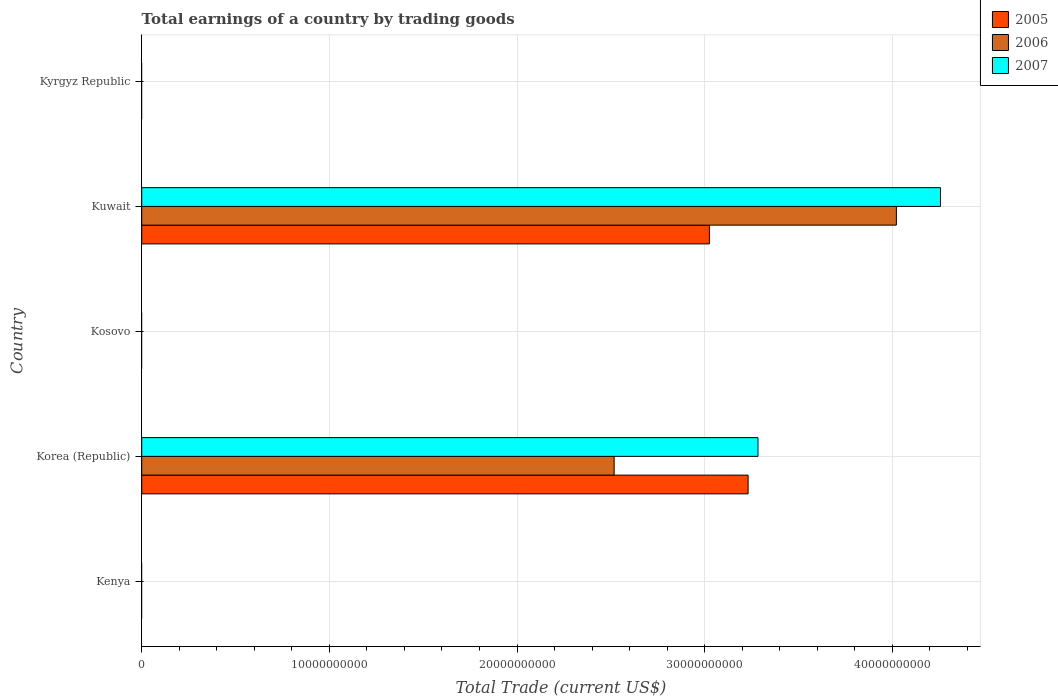Are the number of bars per tick equal to the number of legend labels?
Offer a very short reply. No. Are the number of bars on each tick of the Y-axis equal?
Keep it short and to the point. No. How many bars are there on the 3rd tick from the bottom?
Your response must be concise. 0. What is the label of the 1st group of bars from the top?
Provide a short and direct response. Kyrgyz Republic. In how many cases, is the number of bars for a given country not equal to the number of legend labels?
Provide a short and direct response. 3. What is the total earnings in 2006 in Korea (Republic)?
Provide a short and direct response. 2.52e+1. Across all countries, what is the maximum total earnings in 2006?
Your response must be concise. 4.02e+1. Across all countries, what is the minimum total earnings in 2007?
Your answer should be very brief. 0. In which country was the total earnings in 2006 maximum?
Keep it short and to the point. Kuwait. What is the total total earnings in 2007 in the graph?
Offer a terse response. 7.54e+1. What is the difference between the total earnings in 2005 in Korea (Republic) and that in Kuwait?
Your answer should be very brief. 2.06e+09. What is the average total earnings in 2007 per country?
Offer a terse response. 1.51e+1. What is the difference between the total earnings in 2005 and total earnings in 2007 in Korea (Republic)?
Give a very brief answer. -5.25e+08. In how many countries, is the total earnings in 2007 greater than 2000000000 US$?
Make the answer very short. 2. What is the difference between the highest and the lowest total earnings in 2007?
Offer a very short reply. 4.26e+1. Is it the case that in every country, the sum of the total earnings in 2005 and total earnings in 2006 is greater than the total earnings in 2007?
Offer a very short reply. No. How many bars are there?
Keep it short and to the point. 6. Are all the bars in the graph horizontal?
Give a very brief answer. Yes. How many countries are there in the graph?
Keep it short and to the point. 5. What is the difference between two consecutive major ticks on the X-axis?
Offer a very short reply. 1.00e+1. Are the values on the major ticks of X-axis written in scientific E-notation?
Give a very brief answer. No. Where does the legend appear in the graph?
Your answer should be compact. Top right. How many legend labels are there?
Keep it short and to the point. 3. What is the title of the graph?
Provide a short and direct response. Total earnings of a country by trading goods. What is the label or title of the X-axis?
Your answer should be very brief. Total Trade (current US$). What is the label or title of the Y-axis?
Your response must be concise. Country. What is the Total Trade (current US$) of 2006 in Kenya?
Your answer should be very brief. 0. What is the Total Trade (current US$) of 2005 in Korea (Republic)?
Give a very brief answer. 3.23e+1. What is the Total Trade (current US$) of 2006 in Korea (Republic)?
Make the answer very short. 2.52e+1. What is the Total Trade (current US$) of 2007 in Korea (Republic)?
Offer a terse response. 3.28e+1. What is the Total Trade (current US$) of 2006 in Kosovo?
Offer a very short reply. 0. What is the Total Trade (current US$) in 2007 in Kosovo?
Offer a terse response. 0. What is the Total Trade (current US$) in 2005 in Kuwait?
Offer a very short reply. 3.02e+1. What is the Total Trade (current US$) in 2006 in Kuwait?
Your response must be concise. 4.02e+1. What is the Total Trade (current US$) of 2007 in Kuwait?
Provide a succinct answer. 4.26e+1. What is the Total Trade (current US$) of 2005 in Kyrgyz Republic?
Offer a very short reply. 0. What is the Total Trade (current US$) in 2006 in Kyrgyz Republic?
Provide a succinct answer. 0. Across all countries, what is the maximum Total Trade (current US$) of 2005?
Provide a succinct answer. 3.23e+1. Across all countries, what is the maximum Total Trade (current US$) in 2006?
Offer a very short reply. 4.02e+1. Across all countries, what is the maximum Total Trade (current US$) of 2007?
Offer a very short reply. 4.26e+1. Across all countries, what is the minimum Total Trade (current US$) of 2006?
Your answer should be compact. 0. What is the total Total Trade (current US$) in 2005 in the graph?
Your answer should be compact. 6.26e+1. What is the total Total Trade (current US$) in 2006 in the graph?
Your response must be concise. 6.54e+1. What is the total Total Trade (current US$) of 2007 in the graph?
Offer a very short reply. 7.54e+1. What is the difference between the Total Trade (current US$) in 2005 in Korea (Republic) and that in Kuwait?
Provide a succinct answer. 2.06e+09. What is the difference between the Total Trade (current US$) of 2006 in Korea (Republic) and that in Kuwait?
Give a very brief answer. -1.50e+1. What is the difference between the Total Trade (current US$) in 2007 in Korea (Republic) and that in Kuwait?
Offer a terse response. -9.73e+09. What is the difference between the Total Trade (current US$) in 2005 in Korea (Republic) and the Total Trade (current US$) in 2006 in Kuwait?
Your answer should be compact. -7.90e+09. What is the difference between the Total Trade (current US$) in 2005 in Korea (Republic) and the Total Trade (current US$) in 2007 in Kuwait?
Offer a terse response. -1.03e+1. What is the difference between the Total Trade (current US$) in 2006 in Korea (Republic) and the Total Trade (current US$) in 2007 in Kuwait?
Your response must be concise. -1.74e+1. What is the average Total Trade (current US$) in 2005 per country?
Offer a very short reply. 1.25e+1. What is the average Total Trade (current US$) of 2006 per country?
Make the answer very short. 1.31e+1. What is the average Total Trade (current US$) of 2007 per country?
Give a very brief answer. 1.51e+1. What is the difference between the Total Trade (current US$) in 2005 and Total Trade (current US$) in 2006 in Korea (Republic)?
Give a very brief answer. 7.14e+09. What is the difference between the Total Trade (current US$) of 2005 and Total Trade (current US$) of 2007 in Korea (Republic)?
Your response must be concise. -5.25e+08. What is the difference between the Total Trade (current US$) of 2006 and Total Trade (current US$) of 2007 in Korea (Republic)?
Ensure brevity in your answer.  -7.66e+09. What is the difference between the Total Trade (current US$) in 2005 and Total Trade (current US$) in 2006 in Kuwait?
Your answer should be compact. -9.96e+09. What is the difference between the Total Trade (current US$) in 2005 and Total Trade (current US$) in 2007 in Kuwait?
Provide a succinct answer. -1.23e+1. What is the difference between the Total Trade (current US$) of 2006 and Total Trade (current US$) of 2007 in Kuwait?
Provide a short and direct response. -2.35e+09. What is the ratio of the Total Trade (current US$) in 2005 in Korea (Republic) to that in Kuwait?
Your response must be concise. 1.07. What is the ratio of the Total Trade (current US$) in 2006 in Korea (Republic) to that in Kuwait?
Offer a very short reply. 0.63. What is the ratio of the Total Trade (current US$) of 2007 in Korea (Republic) to that in Kuwait?
Your answer should be very brief. 0.77. What is the difference between the highest and the lowest Total Trade (current US$) in 2005?
Your answer should be compact. 3.23e+1. What is the difference between the highest and the lowest Total Trade (current US$) of 2006?
Provide a short and direct response. 4.02e+1. What is the difference between the highest and the lowest Total Trade (current US$) in 2007?
Offer a very short reply. 4.26e+1. 